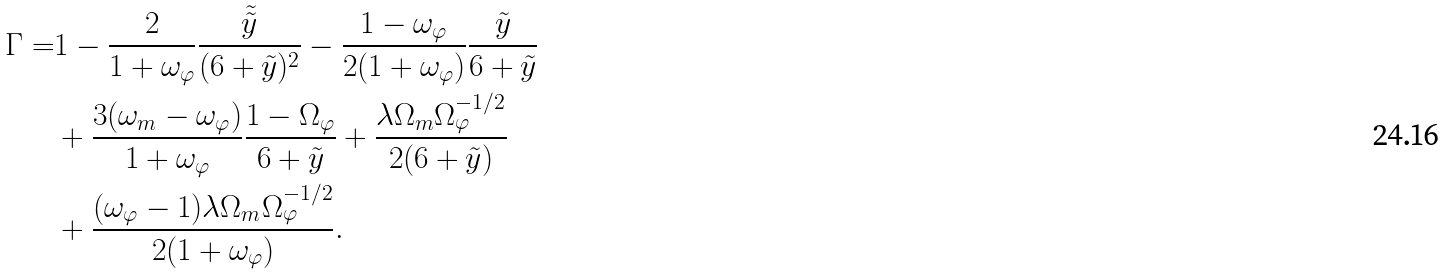<formula> <loc_0><loc_0><loc_500><loc_500>\Gamma = & 1 - \frac { 2 } { 1 + \omega _ { \varphi } } \frac { \tilde { \tilde { y } } } { ( 6 + \tilde { y } ) ^ { 2 } } - \frac { 1 - \omega _ { \varphi } } { 2 ( 1 + \omega _ { \varphi } ) } \frac { \tilde { y } } { 6 + \tilde { y } } \\ & + \frac { 3 ( \omega _ { m } - \omega _ { \varphi } ) } { 1 + \omega _ { \varphi } } \frac { 1 - \Omega _ { \varphi } } { 6 + \tilde { y } } + \frac { \lambda \Omega _ { m } \Omega _ { \varphi } ^ { - 1 / 2 } } { 2 ( 6 + \tilde { y } ) } \\ & + \frac { ( \omega _ { \varphi } - 1 ) \lambda \Omega _ { m } \Omega _ { \varphi } ^ { - 1 / 2 } } { 2 ( 1 + \omega _ { \varphi } ) } .</formula> 